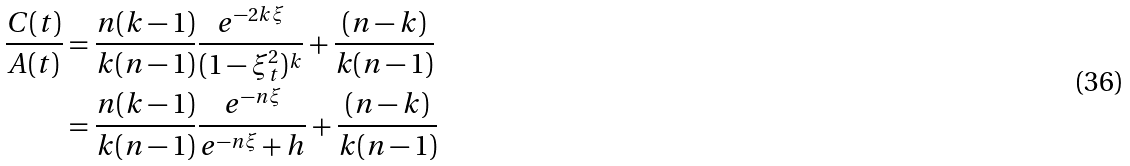Convert formula to latex. <formula><loc_0><loc_0><loc_500><loc_500>\frac { C ( t ) } { A ( t ) } & = \frac { n ( k - 1 ) } { k ( n - 1 ) } \frac { e ^ { - 2 k \xi } } { ( 1 - \xi _ { t } ^ { 2 } ) ^ { k } } + \frac { ( n - k ) } { k ( n - 1 ) } \\ & = \frac { n ( k - 1 ) } { k ( n - 1 ) } \frac { e ^ { - n \xi } } { e ^ { - n \xi } + h } + \frac { ( n - k ) } { k ( n - 1 ) }</formula> 